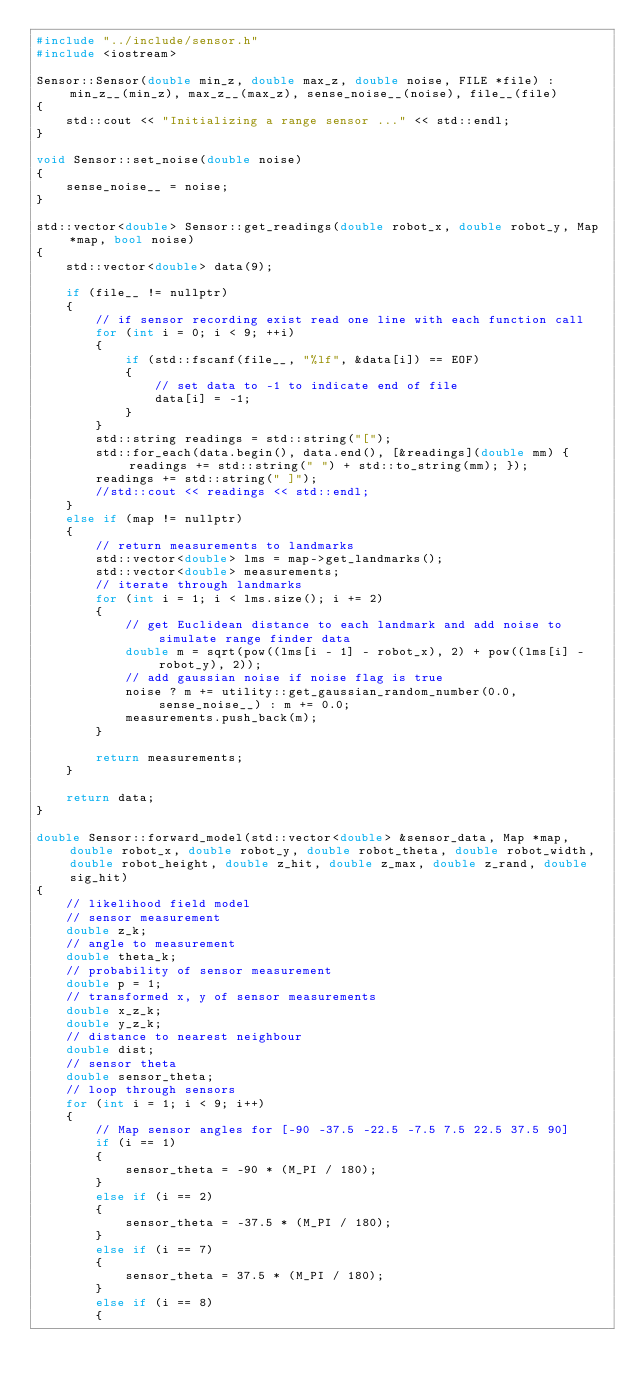<code> <loc_0><loc_0><loc_500><loc_500><_C++_>#include "../include/sensor.h"
#include <iostream>

Sensor::Sensor(double min_z, double max_z, double noise, FILE *file) : min_z__(min_z), max_z__(max_z), sense_noise__(noise), file__(file)
{
    std::cout << "Initializing a range sensor ..." << std::endl;
}

void Sensor::set_noise(double noise)
{
    sense_noise__ = noise;
}

std::vector<double> Sensor::get_readings(double robot_x, double robot_y, Map *map, bool noise)
{
    std::vector<double> data(9);

    if (file__ != nullptr)
    {
        // if sensor recording exist read one line with each function call
        for (int i = 0; i < 9; ++i)
        {
            if (std::fscanf(file__, "%lf", &data[i]) == EOF)
            {
                // set data to -1 to indicate end of file
                data[i] = -1;
            }
        }
        std::string readings = std::string("[");
        std::for_each(data.begin(), data.end(), [&readings](double mm) { readings += std::string(" ") + std::to_string(mm); });
        readings += std::string(" ]");
        //std::cout << readings << std::endl;
    }
    else if (map != nullptr)
    {
        // return measurements to landmarks
        std::vector<double> lms = map->get_landmarks();
        std::vector<double> measurements;
        // iterate through landmarks
        for (int i = 1; i < lms.size(); i += 2)
        {
            // get Euclidean distance to each landmark and add noise to simulate range finder data
            double m = sqrt(pow((lms[i - 1] - robot_x), 2) + pow((lms[i] - robot_y), 2));
            // add gaussian noise if noise flag is true
            noise ? m += utility::get_gaussian_random_number(0.0, sense_noise__) : m += 0.0;
            measurements.push_back(m);
        }

        return measurements;
    }

    return data;
}

double Sensor::forward_model(std::vector<double> &sensor_data, Map *map, double robot_x, double robot_y, double robot_theta, double robot_width, double robot_height, double z_hit, double z_max, double z_rand, double sig_hit)
{
    // likelihood field model
    // sensor measurement
    double z_k;
    // angle to measurement
    double theta_k;
    // probability of sensor measurement
    double p = 1;
    // transformed x, y of sensor measurements
    double x_z_k;
    double y_z_k;
    // distance to nearest neighbour
    double dist;
    // sensor theta
    double sensor_theta;
    // loop through sensors
    for (int i = 1; i < 9; i++)
    {
        // Map sensor angles for [-90 -37.5 -22.5 -7.5 7.5 22.5 37.5 90]
        if (i == 1)
        {
            sensor_theta = -90 * (M_PI / 180);
        }
        else if (i == 2)
        {
            sensor_theta = -37.5 * (M_PI / 180);
        }
        else if (i == 7)
        {
            sensor_theta = 37.5 * (M_PI / 180);
        }
        else if (i == 8)
        {</code> 